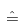<formula> <loc_0><loc_0><loc_500><loc_500>\hat { = }</formula> 